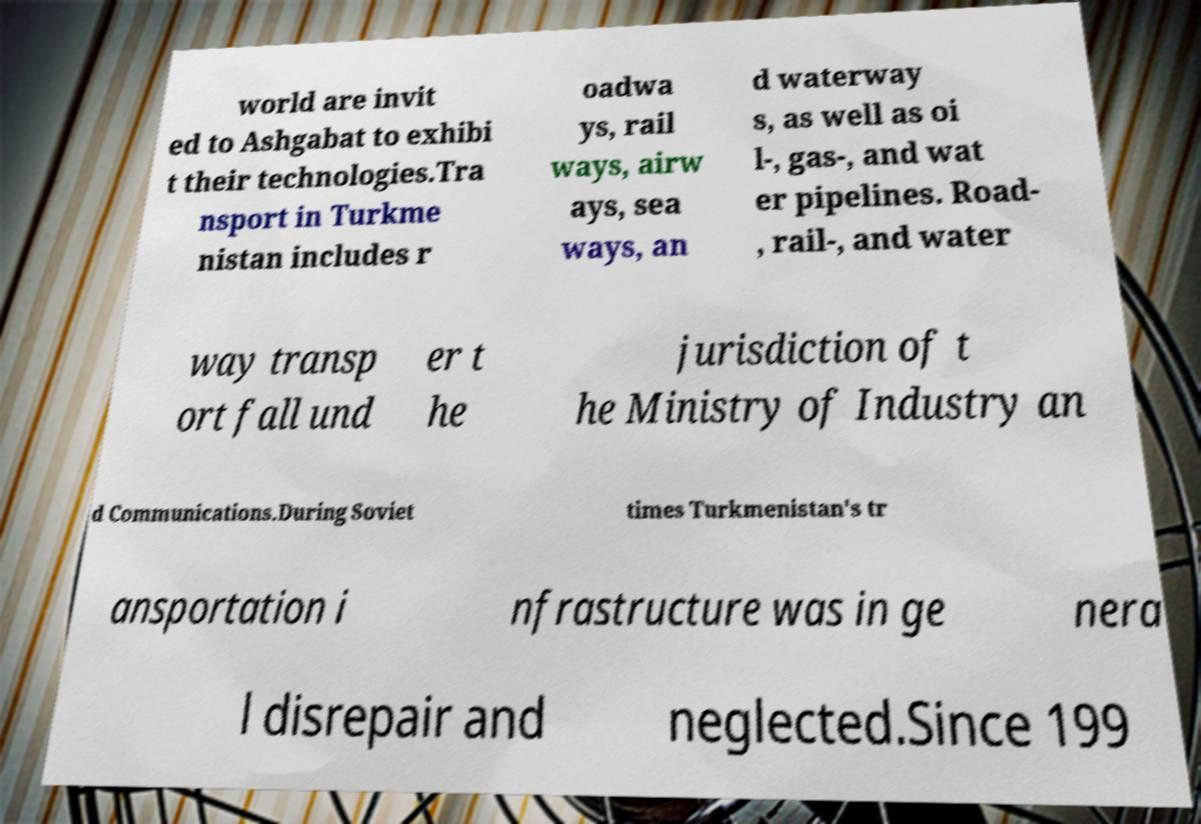There's text embedded in this image that I need extracted. Can you transcribe it verbatim? world are invit ed to Ashgabat to exhibi t their technologies.Tra nsport in Turkme nistan includes r oadwa ys, rail ways, airw ays, sea ways, an d waterway s, as well as oi l-, gas-, and wat er pipelines. Road- , rail-, and water way transp ort fall und er t he jurisdiction of t he Ministry of Industry an d Communications.During Soviet times Turkmenistan's tr ansportation i nfrastructure was in ge nera l disrepair and neglected.Since 199 